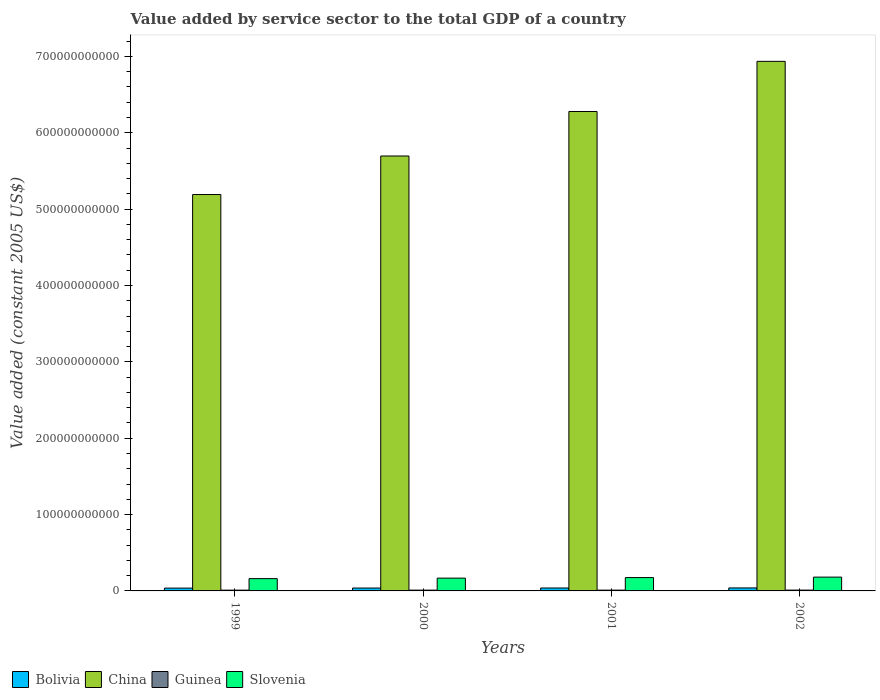How many different coloured bars are there?
Offer a very short reply. 4. How many groups of bars are there?
Make the answer very short. 4. What is the label of the 2nd group of bars from the left?
Your answer should be very brief. 2000. What is the value added by service sector in Guinea in 2001?
Offer a very short reply. 1.04e+09. Across all years, what is the maximum value added by service sector in China?
Ensure brevity in your answer.  6.93e+11. Across all years, what is the minimum value added by service sector in Slovenia?
Offer a terse response. 1.61e+1. What is the total value added by service sector in Slovenia in the graph?
Provide a succinct answer. 6.84e+1. What is the difference between the value added by service sector in Slovenia in 2001 and that in 2002?
Offer a very short reply. -6.23e+08. What is the difference between the value added by service sector in China in 2002 and the value added by service sector in Bolivia in 1999?
Give a very brief answer. 6.90e+11. What is the average value added by service sector in Bolivia per year?
Your answer should be compact. 3.81e+09. In the year 2001, what is the difference between the value added by service sector in Guinea and value added by service sector in Slovenia?
Provide a succinct answer. -1.64e+1. What is the ratio of the value added by service sector in Bolivia in 2000 to that in 2002?
Offer a very short reply. 0.96. What is the difference between the highest and the second highest value added by service sector in Bolivia?
Provide a short and direct response. 7.39e+07. What is the difference between the highest and the lowest value added by service sector in Guinea?
Offer a very short reply. 6.33e+07. In how many years, is the value added by service sector in Bolivia greater than the average value added by service sector in Bolivia taken over all years?
Make the answer very short. 2. Is it the case that in every year, the sum of the value added by service sector in Bolivia and value added by service sector in China is greater than the sum of value added by service sector in Slovenia and value added by service sector in Guinea?
Your answer should be very brief. Yes. What does the 4th bar from the left in 1999 represents?
Ensure brevity in your answer.  Slovenia. Is it the case that in every year, the sum of the value added by service sector in Guinea and value added by service sector in China is greater than the value added by service sector in Bolivia?
Your response must be concise. Yes. How many bars are there?
Make the answer very short. 16. Are all the bars in the graph horizontal?
Offer a terse response. No. How many years are there in the graph?
Your answer should be very brief. 4. What is the difference between two consecutive major ticks on the Y-axis?
Your answer should be compact. 1.00e+11. Where does the legend appear in the graph?
Make the answer very short. Bottom left. How are the legend labels stacked?
Your answer should be very brief. Horizontal. What is the title of the graph?
Provide a succinct answer. Value added by service sector to the total GDP of a country. What is the label or title of the X-axis?
Offer a terse response. Years. What is the label or title of the Y-axis?
Your response must be concise. Value added (constant 2005 US$). What is the Value added (constant 2005 US$) in Bolivia in 1999?
Ensure brevity in your answer.  3.69e+09. What is the Value added (constant 2005 US$) in China in 1999?
Your response must be concise. 5.19e+11. What is the Value added (constant 2005 US$) in Guinea in 1999?
Ensure brevity in your answer.  1.01e+09. What is the Value added (constant 2005 US$) in Slovenia in 1999?
Provide a short and direct response. 1.61e+1. What is the Value added (constant 2005 US$) of Bolivia in 2000?
Ensure brevity in your answer.  3.77e+09. What is the Value added (constant 2005 US$) in China in 2000?
Ensure brevity in your answer.  5.70e+11. What is the Value added (constant 2005 US$) of Guinea in 2000?
Your answer should be compact. 1.02e+09. What is the Value added (constant 2005 US$) of Slovenia in 2000?
Offer a terse response. 1.68e+1. What is the Value added (constant 2005 US$) of Bolivia in 2001?
Provide a short and direct response. 3.85e+09. What is the Value added (constant 2005 US$) of China in 2001?
Keep it short and to the point. 6.28e+11. What is the Value added (constant 2005 US$) in Guinea in 2001?
Offer a terse response. 1.04e+09. What is the Value added (constant 2005 US$) in Slovenia in 2001?
Your answer should be very brief. 1.75e+1. What is the Value added (constant 2005 US$) of Bolivia in 2002?
Make the answer very short. 3.92e+09. What is the Value added (constant 2005 US$) of China in 2002?
Offer a very short reply. 6.93e+11. What is the Value added (constant 2005 US$) in Guinea in 2002?
Keep it short and to the point. 1.07e+09. What is the Value added (constant 2005 US$) in Slovenia in 2002?
Offer a very short reply. 1.81e+1. Across all years, what is the maximum Value added (constant 2005 US$) of Bolivia?
Give a very brief answer. 3.92e+09. Across all years, what is the maximum Value added (constant 2005 US$) in China?
Your answer should be very brief. 6.93e+11. Across all years, what is the maximum Value added (constant 2005 US$) in Guinea?
Provide a short and direct response. 1.07e+09. Across all years, what is the maximum Value added (constant 2005 US$) in Slovenia?
Offer a very short reply. 1.81e+1. Across all years, what is the minimum Value added (constant 2005 US$) in Bolivia?
Provide a succinct answer. 3.69e+09. Across all years, what is the minimum Value added (constant 2005 US$) in China?
Your answer should be very brief. 5.19e+11. Across all years, what is the minimum Value added (constant 2005 US$) of Guinea?
Give a very brief answer. 1.01e+09. Across all years, what is the minimum Value added (constant 2005 US$) in Slovenia?
Your response must be concise. 1.61e+1. What is the total Value added (constant 2005 US$) in Bolivia in the graph?
Ensure brevity in your answer.  1.52e+1. What is the total Value added (constant 2005 US$) in China in the graph?
Your answer should be very brief. 2.41e+12. What is the total Value added (constant 2005 US$) in Guinea in the graph?
Provide a succinct answer. 4.14e+09. What is the total Value added (constant 2005 US$) of Slovenia in the graph?
Offer a very short reply. 6.84e+1. What is the difference between the Value added (constant 2005 US$) of Bolivia in 1999 and that in 2000?
Provide a short and direct response. -7.78e+07. What is the difference between the Value added (constant 2005 US$) of China in 1999 and that in 2000?
Keep it short and to the point. -5.05e+1. What is the difference between the Value added (constant 2005 US$) of Guinea in 1999 and that in 2000?
Ensure brevity in your answer.  -1.71e+07. What is the difference between the Value added (constant 2005 US$) in Slovenia in 1999 and that in 2000?
Make the answer very short. -6.56e+08. What is the difference between the Value added (constant 2005 US$) of Bolivia in 1999 and that in 2001?
Offer a very short reply. -1.52e+08. What is the difference between the Value added (constant 2005 US$) in China in 1999 and that in 2001?
Your response must be concise. -1.09e+11. What is the difference between the Value added (constant 2005 US$) in Guinea in 1999 and that in 2001?
Your answer should be very brief. -3.32e+07. What is the difference between the Value added (constant 2005 US$) in Slovenia in 1999 and that in 2001?
Your response must be concise. -1.37e+09. What is the difference between the Value added (constant 2005 US$) of Bolivia in 1999 and that in 2002?
Your response must be concise. -2.26e+08. What is the difference between the Value added (constant 2005 US$) in China in 1999 and that in 2002?
Your answer should be very brief. -1.74e+11. What is the difference between the Value added (constant 2005 US$) of Guinea in 1999 and that in 2002?
Your answer should be very brief. -6.33e+07. What is the difference between the Value added (constant 2005 US$) in Slovenia in 1999 and that in 2002?
Offer a very short reply. -1.99e+09. What is the difference between the Value added (constant 2005 US$) in Bolivia in 2000 and that in 2001?
Offer a terse response. -7.45e+07. What is the difference between the Value added (constant 2005 US$) in China in 2000 and that in 2001?
Your answer should be very brief. -5.83e+1. What is the difference between the Value added (constant 2005 US$) of Guinea in 2000 and that in 2001?
Offer a very short reply. -1.61e+07. What is the difference between the Value added (constant 2005 US$) in Slovenia in 2000 and that in 2001?
Your answer should be very brief. -7.09e+08. What is the difference between the Value added (constant 2005 US$) of Bolivia in 2000 and that in 2002?
Your response must be concise. -1.48e+08. What is the difference between the Value added (constant 2005 US$) in China in 2000 and that in 2002?
Your answer should be very brief. -1.24e+11. What is the difference between the Value added (constant 2005 US$) of Guinea in 2000 and that in 2002?
Provide a short and direct response. -4.62e+07. What is the difference between the Value added (constant 2005 US$) in Slovenia in 2000 and that in 2002?
Offer a very short reply. -1.33e+09. What is the difference between the Value added (constant 2005 US$) in Bolivia in 2001 and that in 2002?
Ensure brevity in your answer.  -7.39e+07. What is the difference between the Value added (constant 2005 US$) in China in 2001 and that in 2002?
Ensure brevity in your answer.  -6.57e+1. What is the difference between the Value added (constant 2005 US$) of Guinea in 2001 and that in 2002?
Offer a very short reply. -3.01e+07. What is the difference between the Value added (constant 2005 US$) in Slovenia in 2001 and that in 2002?
Keep it short and to the point. -6.23e+08. What is the difference between the Value added (constant 2005 US$) in Bolivia in 1999 and the Value added (constant 2005 US$) in China in 2000?
Make the answer very short. -5.66e+11. What is the difference between the Value added (constant 2005 US$) of Bolivia in 1999 and the Value added (constant 2005 US$) of Guinea in 2000?
Your response must be concise. 2.67e+09. What is the difference between the Value added (constant 2005 US$) in Bolivia in 1999 and the Value added (constant 2005 US$) in Slovenia in 2000?
Offer a very short reply. -1.31e+1. What is the difference between the Value added (constant 2005 US$) of China in 1999 and the Value added (constant 2005 US$) of Guinea in 2000?
Offer a terse response. 5.18e+11. What is the difference between the Value added (constant 2005 US$) in China in 1999 and the Value added (constant 2005 US$) in Slovenia in 2000?
Offer a very short reply. 5.02e+11. What is the difference between the Value added (constant 2005 US$) in Guinea in 1999 and the Value added (constant 2005 US$) in Slovenia in 2000?
Offer a terse response. -1.57e+1. What is the difference between the Value added (constant 2005 US$) in Bolivia in 1999 and the Value added (constant 2005 US$) in China in 2001?
Ensure brevity in your answer.  -6.24e+11. What is the difference between the Value added (constant 2005 US$) of Bolivia in 1999 and the Value added (constant 2005 US$) of Guinea in 2001?
Provide a short and direct response. 2.65e+09. What is the difference between the Value added (constant 2005 US$) of Bolivia in 1999 and the Value added (constant 2005 US$) of Slovenia in 2001?
Provide a short and direct response. -1.38e+1. What is the difference between the Value added (constant 2005 US$) in China in 1999 and the Value added (constant 2005 US$) in Guinea in 2001?
Your response must be concise. 5.18e+11. What is the difference between the Value added (constant 2005 US$) in China in 1999 and the Value added (constant 2005 US$) in Slovenia in 2001?
Your response must be concise. 5.02e+11. What is the difference between the Value added (constant 2005 US$) in Guinea in 1999 and the Value added (constant 2005 US$) in Slovenia in 2001?
Provide a succinct answer. -1.65e+1. What is the difference between the Value added (constant 2005 US$) of Bolivia in 1999 and the Value added (constant 2005 US$) of China in 2002?
Your answer should be compact. -6.90e+11. What is the difference between the Value added (constant 2005 US$) of Bolivia in 1999 and the Value added (constant 2005 US$) of Guinea in 2002?
Keep it short and to the point. 2.62e+09. What is the difference between the Value added (constant 2005 US$) in Bolivia in 1999 and the Value added (constant 2005 US$) in Slovenia in 2002?
Your answer should be very brief. -1.44e+1. What is the difference between the Value added (constant 2005 US$) of China in 1999 and the Value added (constant 2005 US$) of Guinea in 2002?
Give a very brief answer. 5.18e+11. What is the difference between the Value added (constant 2005 US$) of China in 1999 and the Value added (constant 2005 US$) of Slovenia in 2002?
Make the answer very short. 5.01e+11. What is the difference between the Value added (constant 2005 US$) in Guinea in 1999 and the Value added (constant 2005 US$) in Slovenia in 2002?
Your answer should be compact. -1.71e+1. What is the difference between the Value added (constant 2005 US$) in Bolivia in 2000 and the Value added (constant 2005 US$) in China in 2001?
Give a very brief answer. -6.24e+11. What is the difference between the Value added (constant 2005 US$) of Bolivia in 2000 and the Value added (constant 2005 US$) of Guinea in 2001?
Give a very brief answer. 2.73e+09. What is the difference between the Value added (constant 2005 US$) of Bolivia in 2000 and the Value added (constant 2005 US$) of Slovenia in 2001?
Your answer should be very brief. -1.37e+1. What is the difference between the Value added (constant 2005 US$) in China in 2000 and the Value added (constant 2005 US$) in Guinea in 2001?
Ensure brevity in your answer.  5.69e+11. What is the difference between the Value added (constant 2005 US$) of China in 2000 and the Value added (constant 2005 US$) of Slovenia in 2001?
Provide a succinct answer. 5.52e+11. What is the difference between the Value added (constant 2005 US$) in Guinea in 2000 and the Value added (constant 2005 US$) in Slovenia in 2001?
Offer a very short reply. -1.64e+1. What is the difference between the Value added (constant 2005 US$) in Bolivia in 2000 and the Value added (constant 2005 US$) in China in 2002?
Offer a terse response. -6.90e+11. What is the difference between the Value added (constant 2005 US$) of Bolivia in 2000 and the Value added (constant 2005 US$) of Guinea in 2002?
Offer a very short reply. 2.70e+09. What is the difference between the Value added (constant 2005 US$) in Bolivia in 2000 and the Value added (constant 2005 US$) in Slovenia in 2002?
Your answer should be compact. -1.43e+1. What is the difference between the Value added (constant 2005 US$) in China in 2000 and the Value added (constant 2005 US$) in Guinea in 2002?
Keep it short and to the point. 5.68e+11. What is the difference between the Value added (constant 2005 US$) in China in 2000 and the Value added (constant 2005 US$) in Slovenia in 2002?
Ensure brevity in your answer.  5.51e+11. What is the difference between the Value added (constant 2005 US$) in Guinea in 2000 and the Value added (constant 2005 US$) in Slovenia in 2002?
Give a very brief answer. -1.71e+1. What is the difference between the Value added (constant 2005 US$) in Bolivia in 2001 and the Value added (constant 2005 US$) in China in 2002?
Ensure brevity in your answer.  -6.90e+11. What is the difference between the Value added (constant 2005 US$) of Bolivia in 2001 and the Value added (constant 2005 US$) of Guinea in 2002?
Provide a succinct answer. 2.78e+09. What is the difference between the Value added (constant 2005 US$) of Bolivia in 2001 and the Value added (constant 2005 US$) of Slovenia in 2002?
Your answer should be very brief. -1.42e+1. What is the difference between the Value added (constant 2005 US$) in China in 2001 and the Value added (constant 2005 US$) in Guinea in 2002?
Provide a short and direct response. 6.27e+11. What is the difference between the Value added (constant 2005 US$) of China in 2001 and the Value added (constant 2005 US$) of Slovenia in 2002?
Your answer should be compact. 6.10e+11. What is the difference between the Value added (constant 2005 US$) in Guinea in 2001 and the Value added (constant 2005 US$) in Slovenia in 2002?
Ensure brevity in your answer.  -1.70e+1. What is the average Value added (constant 2005 US$) of Bolivia per year?
Make the answer very short. 3.81e+09. What is the average Value added (constant 2005 US$) of China per year?
Give a very brief answer. 6.02e+11. What is the average Value added (constant 2005 US$) in Guinea per year?
Ensure brevity in your answer.  1.03e+09. What is the average Value added (constant 2005 US$) in Slovenia per year?
Offer a terse response. 1.71e+1. In the year 1999, what is the difference between the Value added (constant 2005 US$) of Bolivia and Value added (constant 2005 US$) of China?
Make the answer very short. -5.15e+11. In the year 1999, what is the difference between the Value added (constant 2005 US$) of Bolivia and Value added (constant 2005 US$) of Guinea?
Your answer should be compact. 2.69e+09. In the year 1999, what is the difference between the Value added (constant 2005 US$) of Bolivia and Value added (constant 2005 US$) of Slovenia?
Ensure brevity in your answer.  -1.24e+1. In the year 1999, what is the difference between the Value added (constant 2005 US$) in China and Value added (constant 2005 US$) in Guinea?
Provide a short and direct response. 5.18e+11. In the year 1999, what is the difference between the Value added (constant 2005 US$) in China and Value added (constant 2005 US$) in Slovenia?
Your answer should be compact. 5.03e+11. In the year 1999, what is the difference between the Value added (constant 2005 US$) of Guinea and Value added (constant 2005 US$) of Slovenia?
Your answer should be very brief. -1.51e+1. In the year 2000, what is the difference between the Value added (constant 2005 US$) in Bolivia and Value added (constant 2005 US$) in China?
Offer a very short reply. -5.66e+11. In the year 2000, what is the difference between the Value added (constant 2005 US$) of Bolivia and Value added (constant 2005 US$) of Guinea?
Your response must be concise. 2.75e+09. In the year 2000, what is the difference between the Value added (constant 2005 US$) of Bolivia and Value added (constant 2005 US$) of Slovenia?
Provide a succinct answer. -1.30e+1. In the year 2000, what is the difference between the Value added (constant 2005 US$) in China and Value added (constant 2005 US$) in Guinea?
Offer a terse response. 5.69e+11. In the year 2000, what is the difference between the Value added (constant 2005 US$) in China and Value added (constant 2005 US$) in Slovenia?
Offer a terse response. 5.53e+11. In the year 2000, what is the difference between the Value added (constant 2005 US$) of Guinea and Value added (constant 2005 US$) of Slovenia?
Give a very brief answer. -1.57e+1. In the year 2001, what is the difference between the Value added (constant 2005 US$) of Bolivia and Value added (constant 2005 US$) of China?
Give a very brief answer. -6.24e+11. In the year 2001, what is the difference between the Value added (constant 2005 US$) of Bolivia and Value added (constant 2005 US$) of Guinea?
Keep it short and to the point. 2.81e+09. In the year 2001, what is the difference between the Value added (constant 2005 US$) in Bolivia and Value added (constant 2005 US$) in Slovenia?
Provide a succinct answer. -1.36e+1. In the year 2001, what is the difference between the Value added (constant 2005 US$) in China and Value added (constant 2005 US$) in Guinea?
Your answer should be compact. 6.27e+11. In the year 2001, what is the difference between the Value added (constant 2005 US$) of China and Value added (constant 2005 US$) of Slovenia?
Ensure brevity in your answer.  6.10e+11. In the year 2001, what is the difference between the Value added (constant 2005 US$) in Guinea and Value added (constant 2005 US$) in Slovenia?
Provide a short and direct response. -1.64e+1. In the year 2002, what is the difference between the Value added (constant 2005 US$) of Bolivia and Value added (constant 2005 US$) of China?
Provide a succinct answer. -6.90e+11. In the year 2002, what is the difference between the Value added (constant 2005 US$) of Bolivia and Value added (constant 2005 US$) of Guinea?
Offer a very short reply. 2.85e+09. In the year 2002, what is the difference between the Value added (constant 2005 US$) in Bolivia and Value added (constant 2005 US$) in Slovenia?
Offer a very short reply. -1.42e+1. In the year 2002, what is the difference between the Value added (constant 2005 US$) of China and Value added (constant 2005 US$) of Guinea?
Your answer should be compact. 6.92e+11. In the year 2002, what is the difference between the Value added (constant 2005 US$) in China and Value added (constant 2005 US$) in Slovenia?
Provide a succinct answer. 6.75e+11. In the year 2002, what is the difference between the Value added (constant 2005 US$) of Guinea and Value added (constant 2005 US$) of Slovenia?
Your answer should be very brief. -1.70e+1. What is the ratio of the Value added (constant 2005 US$) in Bolivia in 1999 to that in 2000?
Provide a short and direct response. 0.98. What is the ratio of the Value added (constant 2005 US$) in China in 1999 to that in 2000?
Your response must be concise. 0.91. What is the ratio of the Value added (constant 2005 US$) of Guinea in 1999 to that in 2000?
Provide a short and direct response. 0.98. What is the ratio of the Value added (constant 2005 US$) in Slovenia in 1999 to that in 2000?
Offer a very short reply. 0.96. What is the ratio of the Value added (constant 2005 US$) of Bolivia in 1999 to that in 2001?
Provide a short and direct response. 0.96. What is the ratio of the Value added (constant 2005 US$) in China in 1999 to that in 2001?
Provide a succinct answer. 0.83. What is the ratio of the Value added (constant 2005 US$) of Guinea in 1999 to that in 2001?
Give a very brief answer. 0.97. What is the ratio of the Value added (constant 2005 US$) in Slovenia in 1999 to that in 2001?
Provide a succinct answer. 0.92. What is the ratio of the Value added (constant 2005 US$) of Bolivia in 1999 to that in 2002?
Provide a short and direct response. 0.94. What is the ratio of the Value added (constant 2005 US$) of China in 1999 to that in 2002?
Provide a short and direct response. 0.75. What is the ratio of the Value added (constant 2005 US$) in Guinea in 1999 to that in 2002?
Your response must be concise. 0.94. What is the ratio of the Value added (constant 2005 US$) in Slovenia in 1999 to that in 2002?
Offer a terse response. 0.89. What is the ratio of the Value added (constant 2005 US$) in Bolivia in 2000 to that in 2001?
Keep it short and to the point. 0.98. What is the ratio of the Value added (constant 2005 US$) in China in 2000 to that in 2001?
Your answer should be very brief. 0.91. What is the ratio of the Value added (constant 2005 US$) in Guinea in 2000 to that in 2001?
Provide a succinct answer. 0.98. What is the ratio of the Value added (constant 2005 US$) in Slovenia in 2000 to that in 2001?
Ensure brevity in your answer.  0.96. What is the ratio of the Value added (constant 2005 US$) in Bolivia in 2000 to that in 2002?
Provide a succinct answer. 0.96. What is the ratio of the Value added (constant 2005 US$) of China in 2000 to that in 2002?
Make the answer very short. 0.82. What is the ratio of the Value added (constant 2005 US$) of Guinea in 2000 to that in 2002?
Ensure brevity in your answer.  0.96. What is the ratio of the Value added (constant 2005 US$) of Slovenia in 2000 to that in 2002?
Give a very brief answer. 0.93. What is the ratio of the Value added (constant 2005 US$) in Bolivia in 2001 to that in 2002?
Make the answer very short. 0.98. What is the ratio of the Value added (constant 2005 US$) of China in 2001 to that in 2002?
Provide a short and direct response. 0.91. What is the ratio of the Value added (constant 2005 US$) of Guinea in 2001 to that in 2002?
Offer a very short reply. 0.97. What is the ratio of the Value added (constant 2005 US$) in Slovenia in 2001 to that in 2002?
Provide a short and direct response. 0.97. What is the difference between the highest and the second highest Value added (constant 2005 US$) in Bolivia?
Ensure brevity in your answer.  7.39e+07. What is the difference between the highest and the second highest Value added (constant 2005 US$) of China?
Give a very brief answer. 6.57e+1. What is the difference between the highest and the second highest Value added (constant 2005 US$) of Guinea?
Your answer should be compact. 3.01e+07. What is the difference between the highest and the second highest Value added (constant 2005 US$) in Slovenia?
Your answer should be very brief. 6.23e+08. What is the difference between the highest and the lowest Value added (constant 2005 US$) in Bolivia?
Your answer should be compact. 2.26e+08. What is the difference between the highest and the lowest Value added (constant 2005 US$) of China?
Offer a terse response. 1.74e+11. What is the difference between the highest and the lowest Value added (constant 2005 US$) of Guinea?
Offer a very short reply. 6.33e+07. What is the difference between the highest and the lowest Value added (constant 2005 US$) of Slovenia?
Make the answer very short. 1.99e+09. 